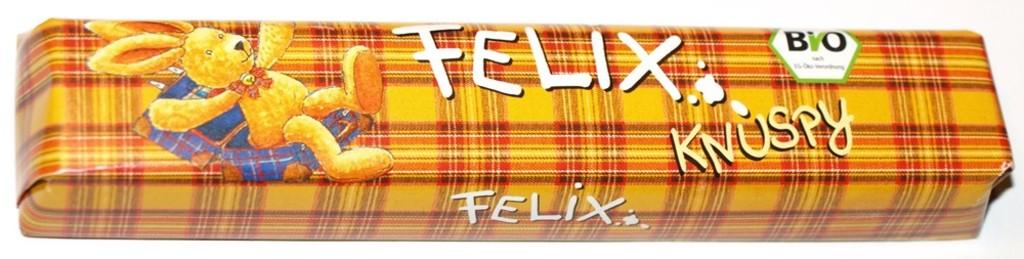What is the main subject in the image? There is an object in the image. What can be seen on the object? The object has some text on it. What type of visual element is present on the object? There is a cartoon on the object. Can you tell me how the clam is talking to the poison in the image? There is no clam or poison present in the image. What type of creature is shown interacting with the cartoon on the object? There is no creature shown interacting with the cartoon on the object; only the object with text and the cartoon are present. 